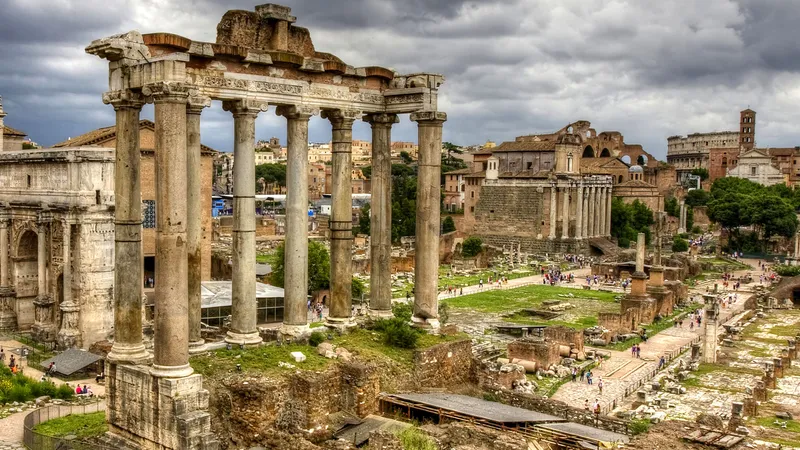Can you explain the significance of the location captured in this image? This image features the Roman Forum, which was the nucleus of political, social, and economic life in ancient Rome. This area was the scene of judicial proceedings, public speeches, and elections; a place where citizens gathered to discuss matters of state and participate in civic rituals. Over time, it also became a repository of various monuments commemorating the great deeds of Roman leaders. Its location at the center of Rome made it a natural meeting point, directly influencing the development and governance of the Roman state. The ruins visible today offer a profound connection to Rome's rich historical tapestry. 